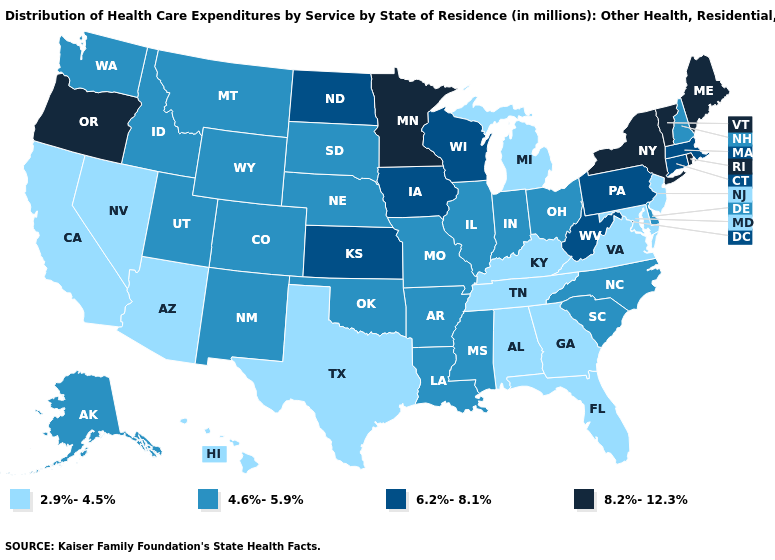Does Missouri have the lowest value in the USA?
Quick response, please. No. Name the states that have a value in the range 6.2%-8.1%?
Write a very short answer. Connecticut, Iowa, Kansas, Massachusetts, North Dakota, Pennsylvania, West Virginia, Wisconsin. Is the legend a continuous bar?
Quick response, please. No. Among the states that border New Mexico , does Texas have the lowest value?
Write a very short answer. Yes. Does Illinois have the highest value in the MidWest?
Give a very brief answer. No. Among the states that border Oregon , does Washington have the highest value?
Keep it brief. Yes. Does Maine have the highest value in the USA?
Give a very brief answer. Yes. What is the value of Oregon?
Be succinct. 8.2%-12.3%. Which states have the highest value in the USA?
Short answer required. Maine, Minnesota, New York, Oregon, Rhode Island, Vermont. Name the states that have a value in the range 8.2%-12.3%?
Quick response, please. Maine, Minnesota, New York, Oregon, Rhode Island, Vermont. Name the states that have a value in the range 2.9%-4.5%?
Be succinct. Alabama, Arizona, California, Florida, Georgia, Hawaii, Kentucky, Maryland, Michigan, Nevada, New Jersey, Tennessee, Texas, Virginia. Does the first symbol in the legend represent the smallest category?
Answer briefly. Yes. What is the lowest value in states that border South Carolina?
Give a very brief answer. 2.9%-4.5%. Which states have the lowest value in the USA?
Give a very brief answer. Alabama, Arizona, California, Florida, Georgia, Hawaii, Kentucky, Maryland, Michigan, Nevada, New Jersey, Tennessee, Texas, Virginia. Name the states that have a value in the range 4.6%-5.9%?
Give a very brief answer. Alaska, Arkansas, Colorado, Delaware, Idaho, Illinois, Indiana, Louisiana, Mississippi, Missouri, Montana, Nebraska, New Hampshire, New Mexico, North Carolina, Ohio, Oklahoma, South Carolina, South Dakota, Utah, Washington, Wyoming. 